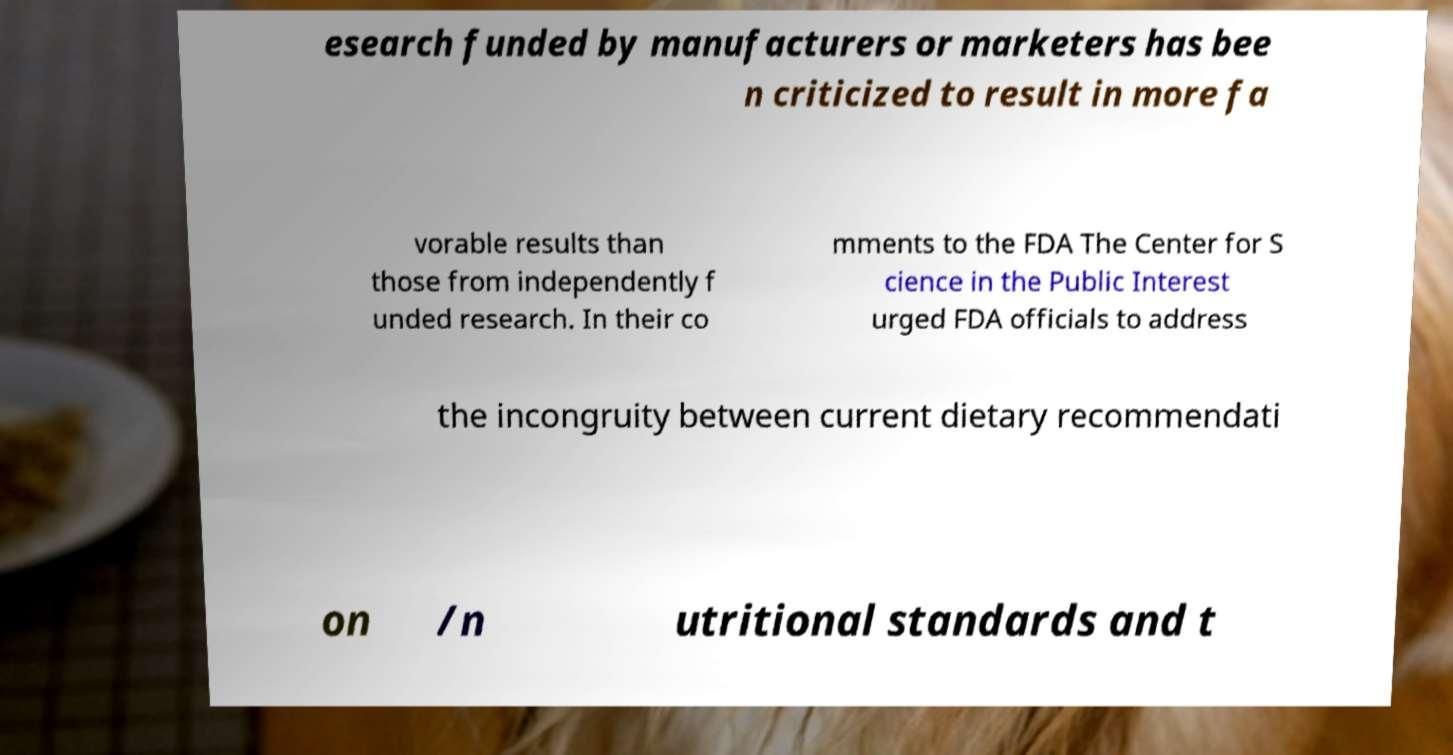Can you accurately transcribe the text from the provided image for me? esearch funded by manufacturers or marketers has bee n criticized to result in more fa vorable results than those from independently f unded research. In their co mments to the FDA The Center for S cience in the Public Interest urged FDA officials to address the incongruity between current dietary recommendati on /n utritional standards and t 